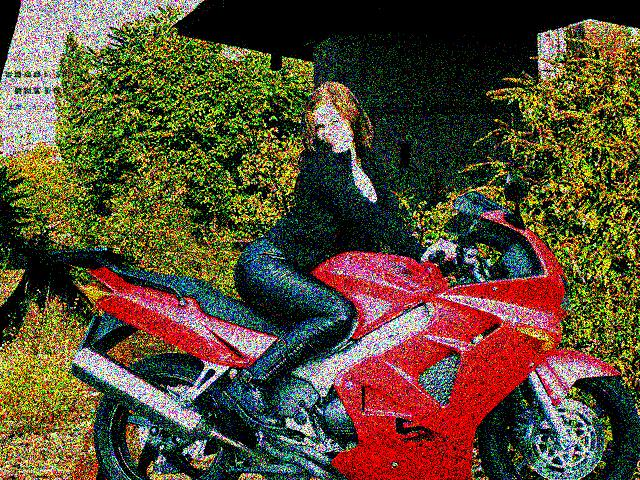Besides the main subject, what other elements grab your attention in this image? While the motorcycle and the person are focal points, the pixelated nature of the image itself is quite notable. The pixelation gives the scene an almost impressionist painting quality, altering the realism expected from a typical photograph. The bright areas of the image seem to be indicative of sunlight filtering through foliage, creating a dappled light effect around the edges. 